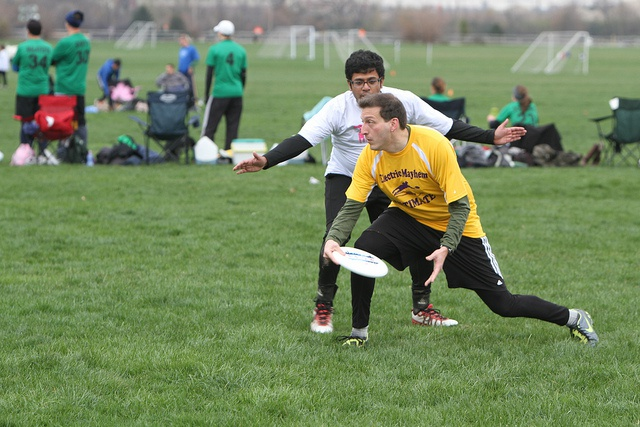Describe the objects in this image and their specific colors. I can see people in gray, black, orange, and gold tones, people in gray, black, lavender, and darkgray tones, people in gray, black, teal, and turquoise tones, people in gray, teal, and black tones, and people in gray, black, teal, and turquoise tones in this image. 